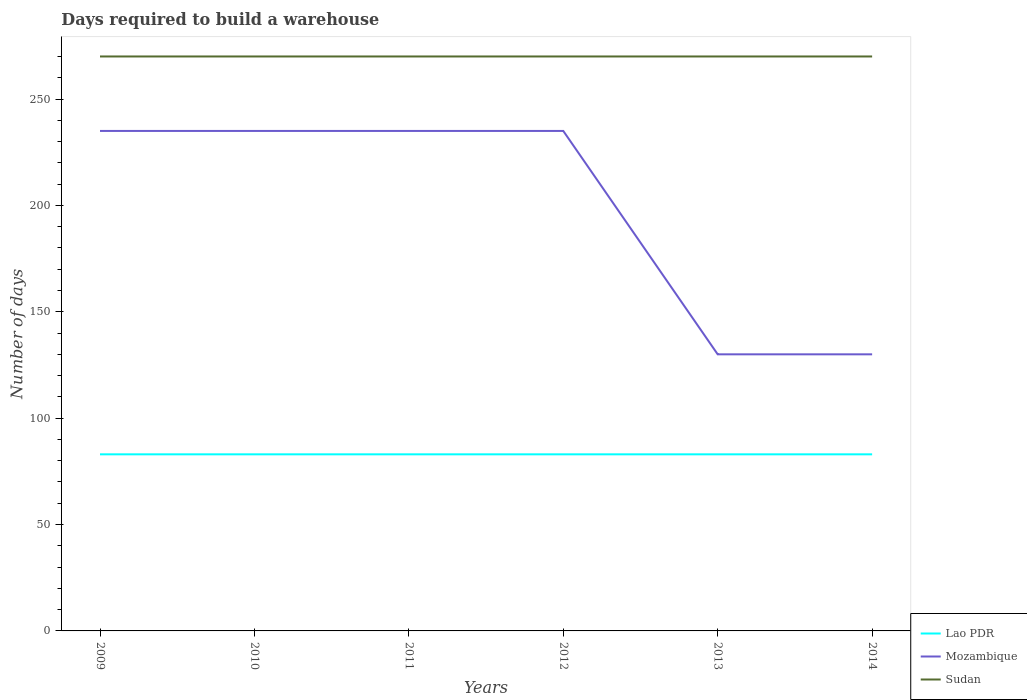How many different coloured lines are there?
Ensure brevity in your answer.  3. Does the line corresponding to Lao PDR intersect with the line corresponding to Sudan?
Offer a terse response. No. Is the number of lines equal to the number of legend labels?
Your response must be concise. Yes. Across all years, what is the maximum days required to build a warehouse in in Lao PDR?
Your answer should be compact. 83. In which year was the days required to build a warehouse in in Mozambique maximum?
Make the answer very short. 2013. What is the total days required to build a warehouse in in Sudan in the graph?
Provide a succinct answer. 0. What is the difference between the highest and the second highest days required to build a warehouse in in Mozambique?
Ensure brevity in your answer.  105. How many lines are there?
Offer a very short reply. 3. What is the difference between two consecutive major ticks on the Y-axis?
Make the answer very short. 50. Does the graph contain grids?
Provide a short and direct response. No. Where does the legend appear in the graph?
Give a very brief answer. Bottom right. What is the title of the graph?
Keep it short and to the point. Days required to build a warehouse. Does "Swaziland" appear as one of the legend labels in the graph?
Offer a very short reply. No. What is the label or title of the Y-axis?
Your response must be concise. Number of days. What is the Number of days in Mozambique in 2009?
Offer a terse response. 235. What is the Number of days in Sudan in 2009?
Keep it short and to the point. 270. What is the Number of days of Lao PDR in 2010?
Offer a terse response. 83. What is the Number of days of Mozambique in 2010?
Offer a terse response. 235. What is the Number of days of Sudan in 2010?
Make the answer very short. 270. What is the Number of days of Lao PDR in 2011?
Your answer should be very brief. 83. What is the Number of days in Mozambique in 2011?
Provide a succinct answer. 235. What is the Number of days in Sudan in 2011?
Give a very brief answer. 270. What is the Number of days in Mozambique in 2012?
Provide a succinct answer. 235. What is the Number of days of Sudan in 2012?
Provide a succinct answer. 270. What is the Number of days in Lao PDR in 2013?
Provide a succinct answer. 83. What is the Number of days in Mozambique in 2013?
Ensure brevity in your answer.  130. What is the Number of days of Sudan in 2013?
Your response must be concise. 270. What is the Number of days of Lao PDR in 2014?
Ensure brevity in your answer.  83. What is the Number of days in Mozambique in 2014?
Your response must be concise. 130. What is the Number of days in Sudan in 2014?
Provide a short and direct response. 270. Across all years, what is the maximum Number of days of Lao PDR?
Give a very brief answer. 83. Across all years, what is the maximum Number of days of Mozambique?
Offer a terse response. 235. Across all years, what is the maximum Number of days in Sudan?
Your response must be concise. 270. Across all years, what is the minimum Number of days in Lao PDR?
Offer a terse response. 83. Across all years, what is the minimum Number of days of Mozambique?
Provide a succinct answer. 130. Across all years, what is the minimum Number of days of Sudan?
Offer a very short reply. 270. What is the total Number of days of Lao PDR in the graph?
Offer a very short reply. 498. What is the total Number of days of Mozambique in the graph?
Your answer should be compact. 1200. What is the total Number of days in Sudan in the graph?
Keep it short and to the point. 1620. What is the difference between the Number of days of Lao PDR in 2009 and that in 2010?
Provide a short and direct response. 0. What is the difference between the Number of days in Mozambique in 2009 and that in 2010?
Provide a succinct answer. 0. What is the difference between the Number of days of Sudan in 2009 and that in 2011?
Make the answer very short. 0. What is the difference between the Number of days in Mozambique in 2009 and that in 2012?
Make the answer very short. 0. What is the difference between the Number of days of Sudan in 2009 and that in 2012?
Keep it short and to the point. 0. What is the difference between the Number of days in Lao PDR in 2009 and that in 2013?
Offer a very short reply. 0. What is the difference between the Number of days in Mozambique in 2009 and that in 2013?
Your response must be concise. 105. What is the difference between the Number of days of Sudan in 2009 and that in 2013?
Your response must be concise. 0. What is the difference between the Number of days of Lao PDR in 2009 and that in 2014?
Give a very brief answer. 0. What is the difference between the Number of days in Mozambique in 2009 and that in 2014?
Your answer should be very brief. 105. What is the difference between the Number of days in Sudan in 2009 and that in 2014?
Make the answer very short. 0. What is the difference between the Number of days in Mozambique in 2010 and that in 2011?
Your answer should be compact. 0. What is the difference between the Number of days of Sudan in 2010 and that in 2011?
Give a very brief answer. 0. What is the difference between the Number of days in Lao PDR in 2010 and that in 2013?
Offer a very short reply. 0. What is the difference between the Number of days in Mozambique in 2010 and that in 2013?
Your response must be concise. 105. What is the difference between the Number of days in Lao PDR in 2010 and that in 2014?
Provide a short and direct response. 0. What is the difference between the Number of days of Mozambique in 2010 and that in 2014?
Your response must be concise. 105. What is the difference between the Number of days of Sudan in 2010 and that in 2014?
Offer a very short reply. 0. What is the difference between the Number of days of Lao PDR in 2011 and that in 2012?
Provide a short and direct response. 0. What is the difference between the Number of days in Mozambique in 2011 and that in 2013?
Make the answer very short. 105. What is the difference between the Number of days in Mozambique in 2011 and that in 2014?
Provide a succinct answer. 105. What is the difference between the Number of days in Sudan in 2011 and that in 2014?
Offer a terse response. 0. What is the difference between the Number of days in Mozambique in 2012 and that in 2013?
Make the answer very short. 105. What is the difference between the Number of days of Sudan in 2012 and that in 2013?
Your answer should be very brief. 0. What is the difference between the Number of days of Mozambique in 2012 and that in 2014?
Ensure brevity in your answer.  105. What is the difference between the Number of days in Sudan in 2012 and that in 2014?
Your answer should be very brief. 0. What is the difference between the Number of days of Mozambique in 2013 and that in 2014?
Your answer should be very brief. 0. What is the difference between the Number of days in Lao PDR in 2009 and the Number of days in Mozambique in 2010?
Offer a terse response. -152. What is the difference between the Number of days of Lao PDR in 2009 and the Number of days of Sudan in 2010?
Make the answer very short. -187. What is the difference between the Number of days of Mozambique in 2009 and the Number of days of Sudan in 2010?
Offer a very short reply. -35. What is the difference between the Number of days in Lao PDR in 2009 and the Number of days in Mozambique in 2011?
Give a very brief answer. -152. What is the difference between the Number of days of Lao PDR in 2009 and the Number of days of Sudan in 2011?
Provide a short and direct response. -187. What is the difference between the Number of days in Mozambique in 2009 and the Number of days in Sudan in 2011?
Offer a terse response. -35. What is the difference between the Number of days in Lao PDR in 2009 and the Number of days in Mozambique in 2012?
Your answer should be very brief. -152. What is the difference between the Number of days in Lao PDR in 2009 and the Number of days in Sudan in 2012?
Offer a very short reply. -187. What is the difference between the Number of days in Mozambique in 2009 and the Number of days in Sudan in 2012?
Ensure brevity in your answer.  -35. What is the difference between the Number of days of Lao PDR in 2009 and the Number of days of Mozambique in 2013?
Ensure brevity in your answer.  -47. What is the difference between the Number of days in Lao PDR in 2009 and the Number of days in Sudan in 2013?
Your response must be concise. -187. What is the difference between the Number of days in Mozambique in 2009 and the Number of days in Sudan in 2013?
Your answer should be compact. -35. What is the difference between the Number of days in Lao PDR in 2009 and the Number of days in Mozambique in 2014?
Keep it short and to the point. -47. What is the difference between the Number of days of Lao PDR in 2009 and the Number of days of Sudan in 2014?
Offer a very short reply. -187. What is the difference between the Number of days of Mozambique in 2009 and the Number of days of Sudan in 2014?
Provide a short and direct response. -35. What is the difference between the Number of days in Lao PDR in 2010 and the Number of days in Mozambique in 2011?
Make the answer very short. -152. What is the difference between the Number of days of Lao PDR in 2010 and the Number of days of Sudan in 2011?
Provide a succinct answer. -187. What is the difference between the Number of days of Mozambique in 2010 and the Number of days of Sudan in 2011?
Your answer should be very brief. -35. What is the difference between the Number of days of Lao PDR in 2010 and the Number of days of Mozambique in 2012?
Provide a succinct answer. -152. What is the difference between the Number of days of Lao PDR in 2010 and the Number of days of Sudan in 2012?
Offer a very short reply. -187. What is the difference between the Number of days of Mozambique in 2010 and the Number of days of Sudan in 2012?
Offer a very short reply. -35. What is the difference between the Number of days in Lao PDR in 2010 and the Number of days in Mozambique in 2013?
Ensure brevity in your answer.  -47. What is the difference between the Number of days in Lao PDR in 2010 and the Number of days in Sudan in 2013?
Keep it short and to the point. -187. What is the difference between the Number of days of Mozambique in 2010 and the Number of days of Sudan in 2013?
Keep it short and to the point. -35. What is the difference between the Number of days in Lao PDR in 2010 and the Number of days in Mozambique in 2014?
Make the answer very short. -47. What is the difference between the Number of days in Lao PDR in 2010 and the Number of days in Sudan in 2014?
Keep it short and to the point. -187. What is the difference between the Number of days in Mozambique in 2010 and the Number of days in Sudan in 2014?
Ensure brevity in your answer.  -35. What is the difference between the Number of days in Lao PDR in 2011 and the Number of days in Mozambique in 2012?
Provide a succinct answer. -152. What is the difference between the Number of days in Lao PDR in 2011 and the Number of days in Sudan in 2012?
Provide a short and direct response. -187. What is the difference between the Number of days in Mozambique in 2011 and the Number of days in Sudan in 2012?
Your answer should be compact. -35. What is the difference between the Number of days in Lao PDR in 2011 and the Number of days in Mozambique in 2013?
Offer a terse response. -47. What is the difference between the Number of days in Lao PDR in 2011 and the Number of days in Sudan in 2013?
Offer a very short reply. -187. What is the difference between the Number of days of Mozambique in 2011 and the Number of days of Sudan in 2013?
Your response must be concise. -35. What is the difference between the Number of days in Lao PDR in 2011 and the Number of days in Mozambique in 2014?
Make the answer very short. -47. What is the difference between the Number of days of Lao PDR in 2011 and the Number of days of Sudan in 2014?
Your response must be concise. -187. What is the difference between the Number of days in Mozambique in 2011 and the Number of days in Sudan in 2014?
Make the answer very short. -35. What is the difference between the Number of days of Lao PDR in 2012 and the Number of days of Mozambique in 2013?
Give a very brief answer. -47. What is the difference between the Number of days in Lao PDR in 2012 and the Number of days in Sudan in 2013?
Your response must be concise. -187. What is the difference between the Number of days of Mozambique in 2012 and the Number of days of Sudan in 2013?
Offer a terse response. -35. What is the difference between the Number of days of Lao PDR in 2012 and the Number of days of Mozambique in 2014?
Ensure brevity in your answer.  -47. What is the difference between the Number of days in Lao PDR in 2012 and the Number of days in Sudan in 2014?
Offer a very short reply. -187. What is the difference between the Number of days of Mozambique in 2012 and the Number of days of Sudan in 2014?
Ensure brevity in your answer.  -35. What is the difference between the Number of days in Lao PDR in 2013 and the Number of days in Mozambique in 2014?
Offer a terse response. -47. What is the difference between the Number of days of Lao PDR in 2013 and the Number of days of Sudan in 2014?
Give a very brief answer. -187. What is the difference between the Number of days in Mozambique in 2013 and the Number of days in Sudan in 2014?
Your answer should be compact. -140. What is the average Number of days of Lao PDR per year?
Offer a terse response. 83. What is the average Number of days of Mozambique per year?
Provide a succinct answer. 200. What is the average Number of days of Sudan per year?
Offer a very short reply. 270. In the year 2009, what is the difference between the Number of days in Lao PDR and Number of days in Mozambique?
Offer a terse response. -152. In the year 2009, what is the difference between the Number of days in Lao PDR and Number of days in Sudan?
Your answer should be compact. -187. In the year 2009, what is the difference between the Number of days of Mozambique and Number of days of Sudan?
Your answer should be compact. -35. In the year 2010, what is the difference between the Number of days in Lao PDR and Number of days in Mozambique?
Ensure brevity in your answer.  -152. In the year 2010, what is the difference between the Number of days in Lao PDR and Number of days in Sudan?
Offer a very short reply. -187. In the year 2010, what is the difference between the Number of days in Mozambique and Number of days in Sudan?
Provide a succinct answer. -35. In the year 2011, what is the difference between the Number of days in Lao PDR and Number of days in Mozambique?
Give a very brief answer. -152. In the year 2011, what is the difference between the Number of days in Lao PDR and Number of days in Sudan?
Provide a succinct answer. -187. In the year 2011, what is the difference between the Number of days of Mozambique and Number of days of Sudan?
Offer a very short reply. -35. In the year 2012, what is the difference between the Number of days in Lao PDR and Number of days in Mozambique?
Give a very brief answer. -152. In the year 2012, what is the difference between the Number of days in Lao PDR and Number of days in Sudan?
Offer a terse response. -187. In the year 2012, what is the difference between the Number of days of Mozambique and Number of days of Sudan?
Your response must be concise. -35. In the year 2013, what is the difference between the Number of days of Lao PDR and Number of days of Mozambique?
Your answer should be compact. -47. In the year 2013, what is the difference between the Number of days in Lao PDR and Number of days in Sudan?
Offer a very short reply. -187. In the year 2013, what is the difference between the Number of days in Mozambique and Number of days in Sudan?
Make the answer very short. -140. In the year 2014, what is the difference between the Number of days of Lao PDR and Number of days of Mozambique?
Provide a succinct answer. -47. In the year 2014, what is the difference between the Number of days in Lao PDR and Number of days in Sudan?
Offer a very short reply. -187. In the year 2014, what is the difference between the Number of days of Mozambique and Number of days of Sudan?
Your answer should be very brief. -140. What is the ratio of the Number of days in Sudan in 2009 to that in 2010?
Your response must be concise. 1. What is the ratio of the Number of days in Lao PDR in 2009 to that in 2011?
Your response must be concise. 1. What is the ratio of the Number of days of Mozambique in 2009 to that in 2011?
Make the answer very short. 1. What is the ratio of the Number of days in Sudan in 2009 to that in 2012?
Offer a terse response. 1. What is the ratio of the Number of days in Lao PDR in 2009 to that in 2013?
Your response must be concise. 1. What is the ratio of the Number of days of Mozambique in 2009 to that in 2013?
Your answer should be compact. 1.81. What is the ratio of the Number of days of Lao PDR in 2009 to that in 2014?
Offer a very short reply. 1. What is the ratio of the Number of days of Mozambique in 2009 to that in 2014?
Give a very brief answer. 1.81. What is the ratio of the Number of days of Sudan in 2009 to that in 2014?
Offer a terse response. 1. What is the ratio of the Number of days in Lao PDR in 2010 to that in 2011?
Provide a short and direct response. 1. What is the ratio of the Number of days in Mozambique in 2010 to that in 2011?
Your answer should be compact. 1. What is the ratio of the Number of days of Lao PDR in 2010 to that in 2012?
Give a very brief answer. 1. What is the ratio of the Number of days in Mozambique in 2010 to that in 2013?
Give a very brief answer. 1.81. What is the ratio of the Number of days of Sudan in 2010 to that in 2013?
Give a very brief answer. 1. What is the ratio of the Number of days of Mozambique in 2010 to that in 2014?
Offer a very short reply. 1.81. What is the ratio of the Number of days of Lao PDR in 2011 to that in 2012?
Give a very brief answer. 1. What is the ratio of the Number of days of Mozambique in 2011 to that in 2012?
Offer a very short reply. 1. What is the ratio of the Number of days in Mozambique in 2011 to that in 2013?
Your answer should be very brief. 1.81. What is the ratio of the Number of days in Lao PDR in 2011 to that in 2014?
Provide a short and direct response. 1. What is the ratio of the Number of days of Mozambique in 2011 to that in 2014?
Offer a terse response. 1.81. What is the ratio of the Number of days in Lao PDR in 2012 to that in 2013?
Give a very brief answer. 1. What is the ratio of the Number of days of Mozambique in 2012 to that in 2013?
Make the answer very short. 1.81. What is the ratio of the Number of days in Mozambique in 2012 to that in 2014?
Keep it short and to the point. 1.81. What is the ratio of the Number of days in Sudan in 2012 to that in 2014?
Give a very brief answer. 1. What is the ratio of the Number of days in Mozambique in 2013 to that in 2014?
Your answer should be compact. 1. What is the ratio of the Number of days in Sudan in 2013 to that in 2014?
Provide a short and direct response. 1. What is the difference between the highest and the second highest Number of days of Mozambique?
Offer a very short reply. 0. What is the difference between the highest and the lowest Number of days in Mozambique?
Your answer should be very brief. 105. What is the difference between the highest and the lowest Number of days of Sudan?
Ensure brevity in your answer.  0. 